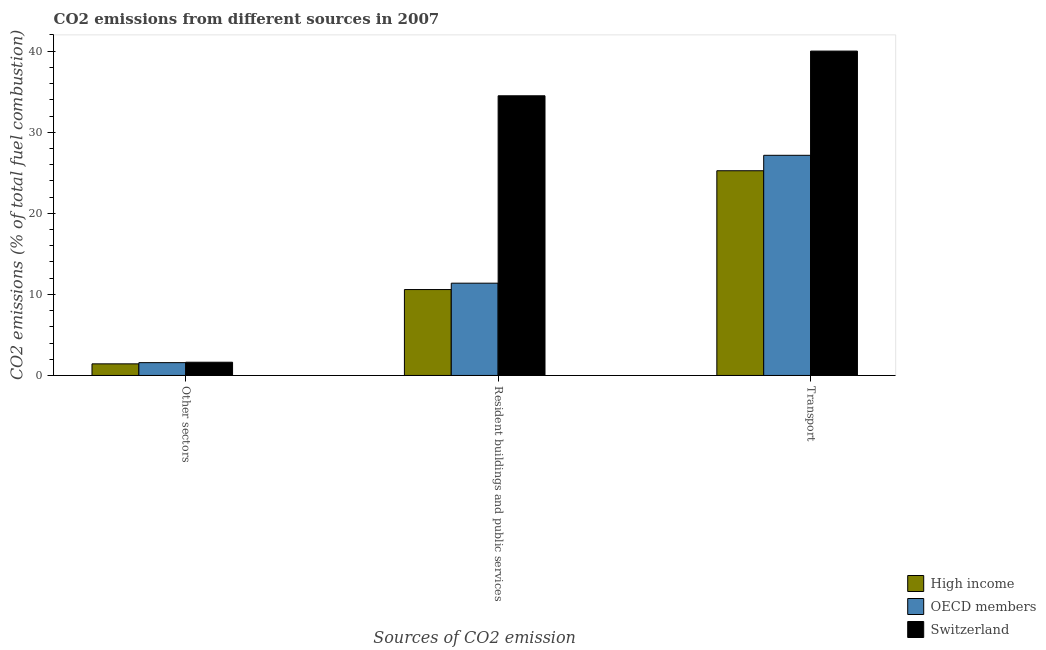Are the number of bars per tick equal to the number of legend labels?
Provide a succinct answer. Yes. Are the number of bars on each tick of the X-axis equal?
Offer a very short reply. Yes. How many bars are there on the 2nd tick from the left?
Offer a very short reply. 3. How many bars are there on the 3rd tick from the right?
Provide a short and direct response. 3. What is the label of the 1st group of bars from the left?
Make the answer very short. Other sectors. What is the percentage of co2 emissions from other sectors in OECD members?
Your answer should be compact. 1.58. Across all countries, what is the maximum percentage of co2 emissions from resident buildings and public services?
Provide a short and direct response. 34.5. Across all countries, what is the minimum percentage of co2 emissions from other sectors?
Your answer should be very brief. 1.43. In which country was the percentage of co2 emissions from transport maximum?
Keep it short and to the point. Switzerland. What is the total percentage of co2 emissions from transport in the graph?
Make the answer very short. 92.43. What is the difference between the percentage of co2 emissions from resident buildings and public services in OECD members and that in Switzerland?
Provide a short and direct response. -23.12. What is the difference between the percentage of co2 emissions from other sectors in High income and the percentage of co2 emissions from resident buildings and public services in Switzerland?
Give a very brief answer. -33.07. What is the average percentage of co2 emissions from transport per country?
Your answer should be compact. 30.81. What is the difference between the percentage of co2 emissions from resident buildings and public services and percentage of co2 emissions from transport in High income?
Your response must be concise. -14.66. What is the ratio of the percentage of co2 emissions from resident buildings and public services in High income to that in Switzerland?
Give a very brief answer. 0.31. Is the percentage of co2 emissions from resident buildings and public services in High income less than that in Switzerland?
Ensure brevity in your answer.  Yes. What is the difference between the highest and the second highest percentage of co2 emissions from other sectors?
Your answer should be very brief. 0.05. What is the difference between the highest and the lowest percentage of co2 emissions from resident buildings and public services?
Provide a succinct answer. 23.9. In how many countries, is the percentage of co2 emissions from other sectors greater than the average percentage of co2 emissions from other sectors taken over all countries?
Your answer should be very brief. 2. What does the 1st bar from the left in Other sectors represents?
Provide a succinct answer. High income. What does the 2nd bar from the right in Resident buildings and public services represents?
Offer a terse response. OECD members. How many bars are there?
Offer a terse response. 9. Are all the bars in the graph horizontal?
Keep it short and to the point. No. How many countries are there in the graph?
Offer a terse response. 3. Are the values on the major ticks of Y-axis written in scientific E-notation?
Provide a short and direct response. No. Does the graph contain any zero values?
Give a very brief answer. No. Does the graph contain grids?
Keep it short and to the point. No. Where does the legend appear in the graph?
Your response must be concise. Bottom right. How many legend labels are there?
Your response must be concise. 3. What is the title of the graph?
Provide a short and direct response. CO2 emissions from different sources in 2007. Does "Gambia, The" appear as one of the legend labels in the graph?
Give a very brief answer. No. What is the label or title of the X-axis?
Provide a short and direct response. Sources of CO2 emission. What is the label or title of the Y-axis?
Give a very brief answer. CO2 emissions (% of total fuel combustion). What is the CO2 emissions (% of total fuel combustion) of High income in Other sectors?
Offer a very short reply. 1.43. What is the CO2 emissions (% of total fuel combustion) of OECD members in Other sectors?
Offer a very short reply. 1.58. What is the CO2 emissions (% of total fuel combustion) of Switzerland in Other sectors?
Your response must be concise. 1.63. What is the CO2 emissions (% of total fuel combustion) in High income in Resident buildings and public services?
Your answer should be very brief. 10.6. What is the CO2 emissions (% of total fuel combustion) of OECD members in Resident buildings and public services?
Keep it short and to the point. 11.38. What is the CO2 emissions (% of total fuel combustion) in Switzerland in Resident buildings and public services?
Offer a terse response. 34.5. What is the CO2 emissions (% of total fuel combustion) of High income in Transport?
Your answer should be compact. 25.25. What is the CO2 emissions (% of total fuel combustion) of OECD members in Transport?
Your response must be concise. 27.16. What is the CO2 emissions (% of total fuel combustion) in Switzerland in Transport?
Give a very brief answer. 40.01. Across all Sources of CO2 emission, what is the maximum CO2 emissions (% of total fuel combustion) of High income?
Make the answer very short. 25.25. Across all Sources of CO2 emission, what is the maximum CO2 emissions (% of total fuel combustion) of OECD members?
Give a very brief answer. 27.16. Across all Sources of CO2 emission, what is the maximum CO2 emissions (% of total fuel combustion) in Switzerland?
Your answer should be compact. 40.01. Across all Sources of CO2 emission, what is the minimum CO2 emissions (% of total fuel combustion) in High income?
Give a very brief answer. 1.43. Across all Sources of CO2 emission, what is the minimum CO2 emissions (% of total fuel combustion) of OECD members?
Offer a very short reply. 1.58. Across all Sources of CO2 emission, what is the minimum CO2 emissions (% of total fuel combustion) in Switzerland?
Keep it short and to the point. 1.63. What is the total CO2 emissions (% of total fuel combustion) in High income in the graph?
Ensure brevity in your answer.  37.28. What is the total CO2 emissions (% of total fuel combustion) in OECD members in the graph?
Provide a short and direct response. 40.12. What is the total CO2 emissions (% of total fuel combustion) of Switzerland in the graph?
Give a very brief answer. 76.15. What is the difference between the CO2 emissions (% of total fuel combustion) in High income in Other sectors and that in Resident buildings and public services?
Offer a terse response. -9.17. What is the difference between the CO2 emissions (% of total fuel combustion) of OECD members in Other sectors and that in Resident buildings and public services?
Offer a terse response. -9.8. What is the difference between the CO2 emissions (% of total fuel combustion) of Switzerland in Other sectors and that in Resident buildings and public services?
Keep it short and to the point. -32.87. What is the difference between the CO2 emissions (% of total fuel combustion) of High income in Other sectors and that in Transport?
Ensure brevity in your answer.  -23.82. What is the difference between the CO2 emissions (% of total fuel combustion) of OECD members in Other sectors and that in Transport?
Provide a succinct answer. -25.58. What is the difference between the CO2 emissions (% of total fuel combustion) of Switzerland in Other sectors and that in Transport?
Give a very brief answer. -38.38. What is the difference between the CO2 emissions (% of total fuel combustion) in High income in Resident buildings and public services and that in Transport?
Make the answer very short. -14.66. What is the difference between the CO2 emissions (% of total fuel combustion) of OECD members in Resident buildings and public services and that in Transport?
Provide a succinct answer. -15.78. What is the difference between the CO2 emissions (% of total fuel combustion) in Switzerland in Resident buildings and public services and that in Transport?
Give a very brief answer. -5.51. What is the difference between the CO2 emissions (% of total fuel combustion) in High income in Other sectors and the CO2 emissions (% of total fuel combustion) in OECD members in Resident buildings and public services?
Offer a terse response. -9.95. What is the difference between the CO2 emissions (% of total fuel combustion) in High income in Other sectors and the CO2 emissions (% of total fuel combustion) in Switzerland in Resident buildings and public services?
Your response must be concise. -33.07. What is the difference between the CO2 emissions (% of total fuel combustion) of OECD members in Other sectors and the CO2 emissions (% of total fuel combustion) of Switzerland in Resident buildings and public services?
Your response must be concise. -32.92. What is the difference between the CO2 emissions (% of total fuel combustion) of High income in Other sectors and the CO2 emissions (% of total fuel combustion) of OECD members in Transport?
Offer a terse response. -25.73. What is the difference between the CO2 emissions (% of total fuel combustion) of High income in Other sectors and the CO2 emissions (% of total fuel combustion) of Switzerland in Transport?
Provide a succinct answer. -38.58. What is the difference between the CO2 emissions (% of total fuel combustion) of OECD members in Other sectors and the CO2 emissions (% of total fuel combustion) of Switzerland in Transport?
Provide a short and direct response. -38.43. What is the difference between the CO2 emissions (% of total fuel combustion) in High income in Resident buildings and public services and the CO2 emissions (% of total fuel combustion) in OECD members in Transport?
Ensure brevity in your answer.  -16.56. What is the difference between the CO2 emissions (% of total fuel combustion) of High income in Resident buildings and public services and the CO2 emissions (% of total fuel combustion) of Switzerland in Transport?
Your answer should be very brief. -29.42. What is the difference between the CO2 emissions (% of total fuel combustion) in OECD members in Resident buildings and public services and the CO2 emissions (% of total fuel combustion) in Switzerland in Transport?
Offer a terse response. -28.63. What is the average CO2 emissions (% of total fuel combustion) in High income per Sources of CO2 emission?
Make the answer very short. 12.43. What is the average CO2 emissions (% of total fuel combustion) in OECD members per Sources of CO2 emission?
Your answer should be compact. 13.37. What is the average CO2 emissions (% of total fuel combustion) of Switzerland per Sources of CO2 emission?
Offer a terse response. 25.38. What is the difference between the CO2 emissions (% of total fuel combustion) of High income and CO2 emissions (% of total fuel combustion) of OECD members in Other sectors?
Your answer should be compact. -0.15. What is the difference between the CO2 emissions (% of total fuel combustion) of High income and CO2 emissions (% of total fuel combustion) of Switzerland in Other sectors?
Provide a succinct answer. -0.2. What is the difference between the CO2 emissions (% of total fuel combustion) of OECD members and CO2 emissions (% of total fuel combustion) of Switzerland in Other sectors?
Your response must be concise. -0.05. What is the difference between the CO2 emissions (% of total fuel combustion) in High income and CO2 emissions (% of total fuel combustion) in OECD members in Resident buildings and public services?
Ensure brevity in your answer.  -0.79. What is the difference between the CO2 emissions (% of total fuel combustion) of High income and CO2 emissions (% of total fuel combustion) of Switzerland in Resident buildings and public services?
Your response must be concise. -23.9. What is the difference between the CO2 emissions (% of total fuel combustion) in OECD members and CO2 emissions (% of total fuel combustion) in Switzerland in Resident buildings and public services?
Offer a terse response. -23.12. What is the difference between the CO2 emissions (% of total fuel combustion) in High income and CO2 emissions (% of total fuel combustion) in OECD members in Transport?
Your answer should be compact. -1.9. What is the difference between the CO2 emissions (% of total fuel combustion) in High income and CO2 emissions (% of total fuel combustion) in Switzerland in Transport?
Your response must be concise. -14.76. What is the difference between the CO2 emissions (% of total fuel combustion) in OECD members and CO2 emissions (% of total fuel combustion) in Switzerland in Transport?
Offer a terse response. -12.86. What is the ratio of the CO2 emissions (% of total fuel combustion) in High income in Other sectors to that in Resident buildings and public services?
Ensure brevity in your answer.  0.14. What is the ratio of the CO2 emissions (% of total fuel combustion) in OECD members in Other sectors to that in Resident buildings and public services?
Give a very brief answer. 0.14. What is the ratio of the CO2 emissions (% of total fuel combustion) in Switzerland in Other sectors to that in Resident buildings and public services?
Offer a very short reply. 0.05. What is the ratio of the CO2 emissions (% of total fuel combustion) in High income in Other sectors to that in Transport?
Your answer should be very brief. 0.06. What is the ratio of the CO2 emissions (% of total fuel combustion) in OECD members in Other sectors to that in Transport?
Keep it short and to the point. 0.06. What is the ratio of the CO2 emissions (% of total fuel combustion) of Switzerland in Other sectors to that in Transport?
Keep it short and to the point. 0.04. What is the ratio of the CO2 emissions (% of total fuel combustion) in High income in Resident buildings and public services to that in Transport?
Keep it short and to the point. 0.42. What is the ratio of the CO2 emissions (% of total fuel combustion) in OECD members in Resident buildings and public services to that in Transport?
Offer a terse response. 0.42. What is the ratio of the CO2 emissions (% of total fuel combustion) of Switzerland in Resident buildings and public services to that in Transport?
Your answer should be very brief. 0.86. What is the difference between the highest and the second highest CO2 emissions (% of total fuel combustion) in High income?
Ensure brevity in your answer.  14.66. What is the difference between the highest and the second highest CO2 emissions (% of total fuel combustion) of OECD members?
Keep it short and to the point. 15.78. What is the difference between the highest and the second highest CO2 emissions (% of total fuel combustion) of Switzerland?
Make the answer very short. 5.51. What is the difference between the highest and the lowest CO2 emissions (% of total fuel combustion) of High income?
Ensure brevity in your answer.  23.82. What is the difference between the highest and the lowest CO2 emissions (% of total fuel combustion) of OECD members?
Make the answer very short. 25.58. What is the difference between the highest and the lowest CO2 emissions (% of total fuel combustion) of Switzerland?
Your response must be concise. 38.38. 